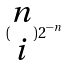Convert formula to latex. <formula><loc_0><loc_0><loc_500><loc_500>( \begin{matrix} n \\ i \end{matrix} ) 2 ^ { - n }</formula> 